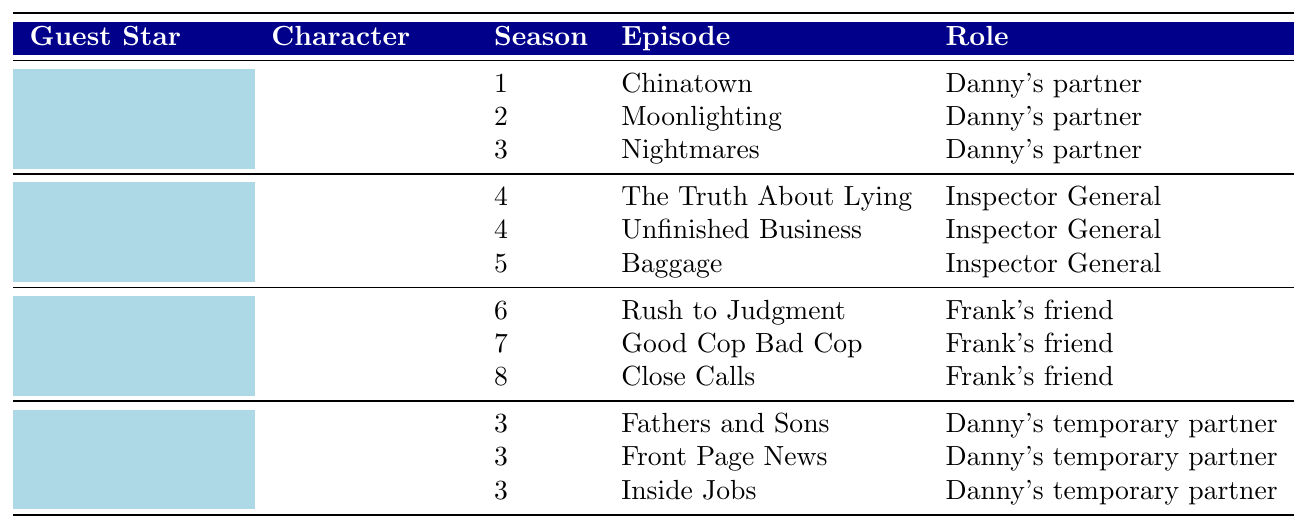What character does Jennifer Esposito portray? The table lists Jennifer Esposito under the "Guest Star" column, and her corresponding "Character" is mentioned as Jackie Curatola.
Answer: Jackie Curatola How many episodes did Bebe Neuwirth appear in? Bebe Neuwirth is listed with three episodes under the "Episodes" column, which can be counted directly from the "Episode" entries.
Answer: 3 In which seasons did Treat Williams guest star? The table shows that Treat Williams appeared in three consecutive seasons: 6, 7, and 8.
Answer: Seasons 6, 7, and 8 What role did Megan Ketch play during her guest appearances? Under the "Role" column for Megan Ketch, it is consistently stated as "Danny's temporary partner" for all her listed episodes.
Answer: Danny's temporary partner Is it true that Bebe Neuwirth's character appeared more times than Jennifer Esposito's character? Bebe Neuwirth has three appearances, while Jennifer Esposito also has three, making it false that Bebe's character appeared more times.
Answer: No Which guest star had the most episodes as listed in the table? By counting the episodes listed for each guest star, both Jennifer Esposito and Bebe Neuwirth had the highest with three episodes each, while others had less.
Answer: Tie between Jennifer Esposito and Bebe Neuwirth What is the relationship of Lenny Ross to Frank? The table indicates that Lenny Ross, played by Treat Williams, is described as "Frank's friend" in all three of his episodes.
Answer: Frank's friend How many guest stars played the role of Danny's partner across all episodes? Jennifer Esposito and Megan Ketch both played the role of Danny's partner, so the total count of distinct guest stars in that role is two.
Answer: 2 In which episodes did Jackie Curatola appear? The table specifies that Jackie Curatola appeared in three episodes, named "Chinatown," "Moonlighting," and "Nightmares," which can be listed from the "Episodes" column.
Answer: Chinatown, Moonlighting, Nightmares Which season featured the most guest stars? By evaluating the provided data, it's clear that all guest stars span across different seasons; no single season has more guest stars than the others since each has unique names.
Answer: None, they all appear in separate seasons 